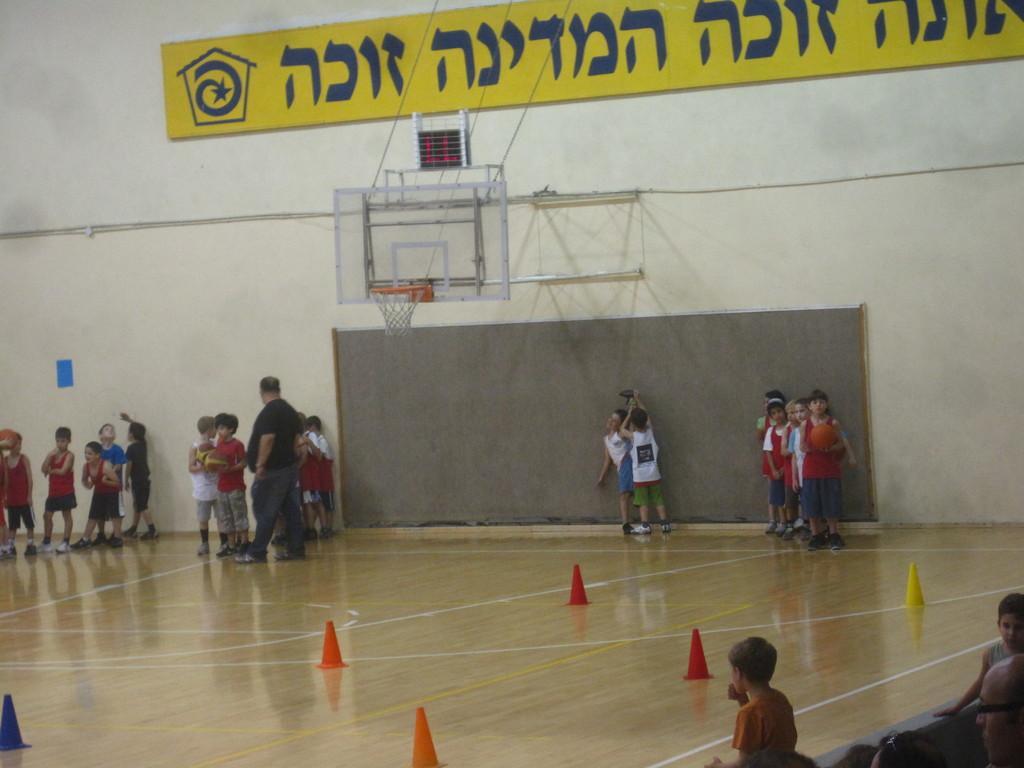Please provide a concise description of this image. In this image I can see the group of people standing on the stage. These people are wearing the different color dresses. I can also see the cones on the floor which are in yellow, red, orange and blue color. To the right I can see few more people. In the back there is a wall and I can see the yellow color board. I can also see the goal basket to the wall. 